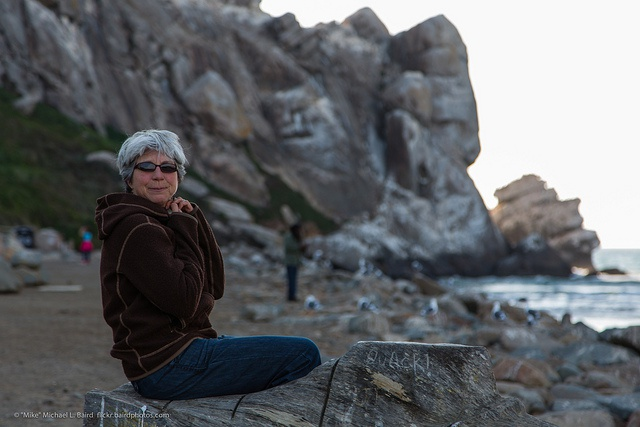Describe the objects in this image and their specific colors. I can see people in gray, black, maroon, and navy tones, people in gray, black, and purple tones, people in gray, black, purple, and blue tones, bird in gray and black tones, and bird in gray and darkgray tones in this image. 